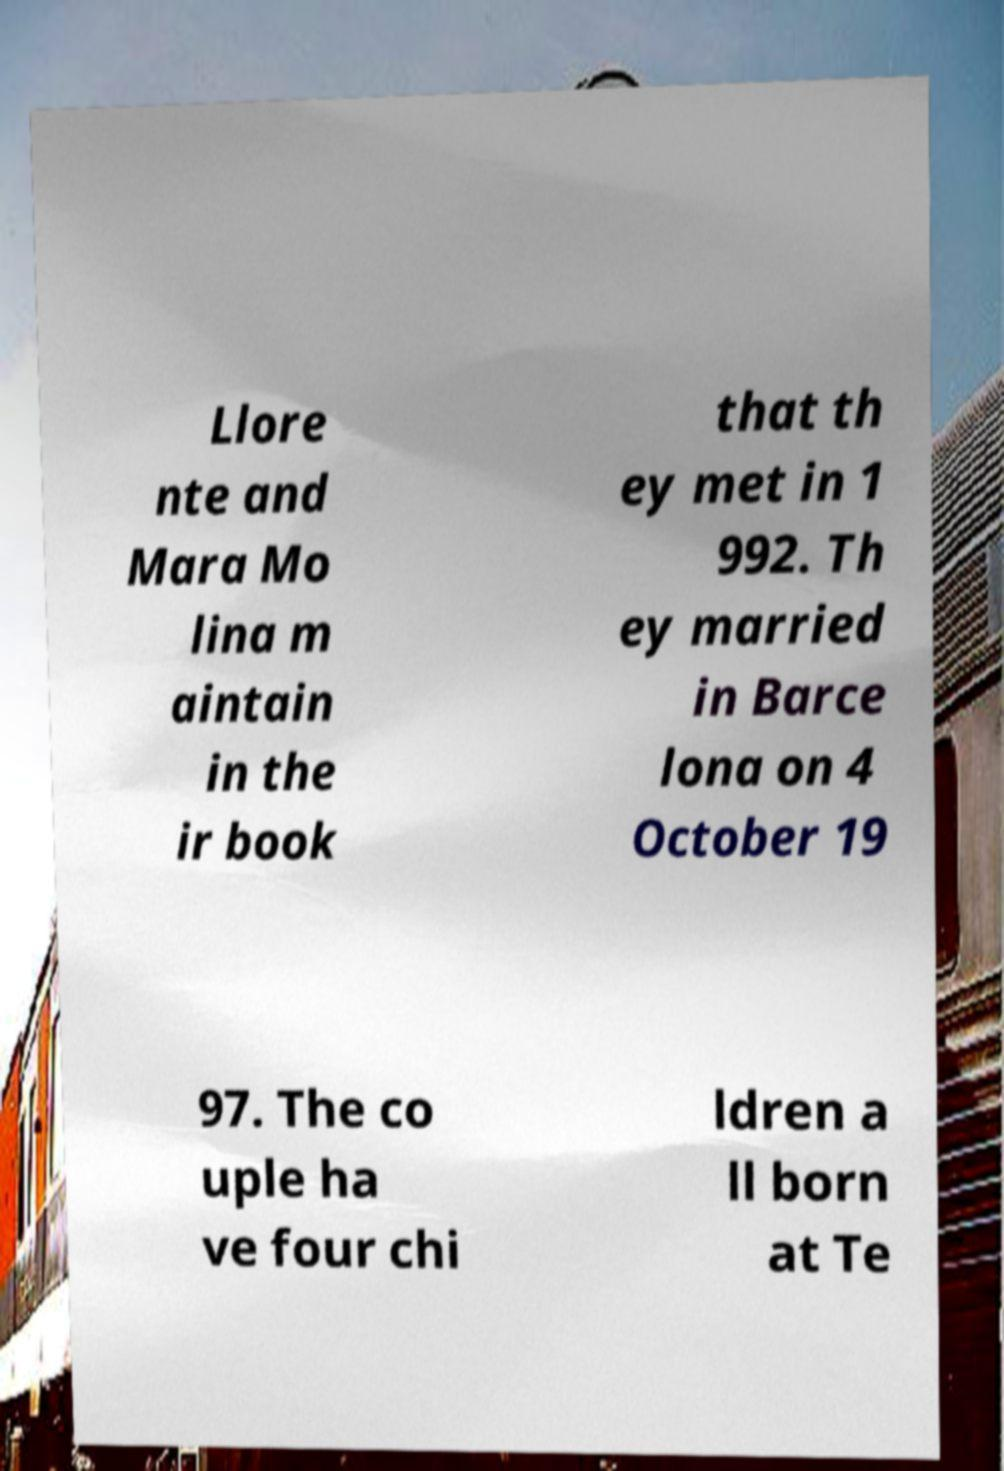There's text embedded in this image that I need extracted. Can you transcribe it verbatim? Llore nte and Mara Mo lina m aintain in the ir book that th ey met in 1 992. Th ey married in Barce lona on 4 October 19 97. The co uple ha ve four chi ldren a ll born at Te 